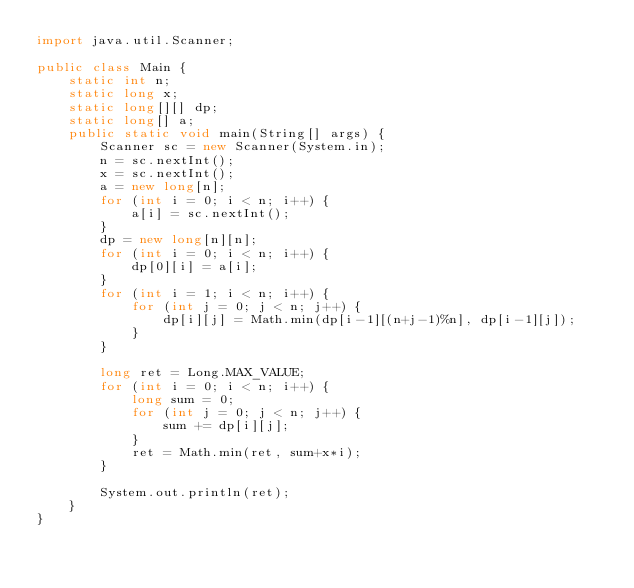Convert code to text. <code><loc_0><loc_0><loc_500><loc_500><_Java_>import java.util.Scanner;

public class Main {
    static int n;
    static long x;
    static long[][] dp;
    static long[] a;
    public static void main(String[] args) {
        Scanner sc = new Scanner(System.in);
        n = sc.nextInt();
        x = sc.nextInt();
        a = new long[n];
        for (int i = 0; i < n; i++) {
            a[i] = sc.nextInt();
        }
        dp = new long[n][n];
        for (int i = 0; i < n; i++) {
            dp[0][i] = a[i];
        }
        for (int i = 1; i < n; i++) {
            for (int j = 0; j < n; j++) {
                dp[i][j] = Math.min(dp[i-1][(n+j-1)%n], dp[i-1][j]);
            }
        }

        long ret = Long.MAX_VALUE;
        for (int i = 0; i < n; i++) {
            long sum = 0;
            for (int j = 0; j < n; j++) {
                sum += dp[i][j];
            }
            ret = Math.min(ret, sum+x*i);
        }

        System.out.println(ret);
    }
}
</code> 